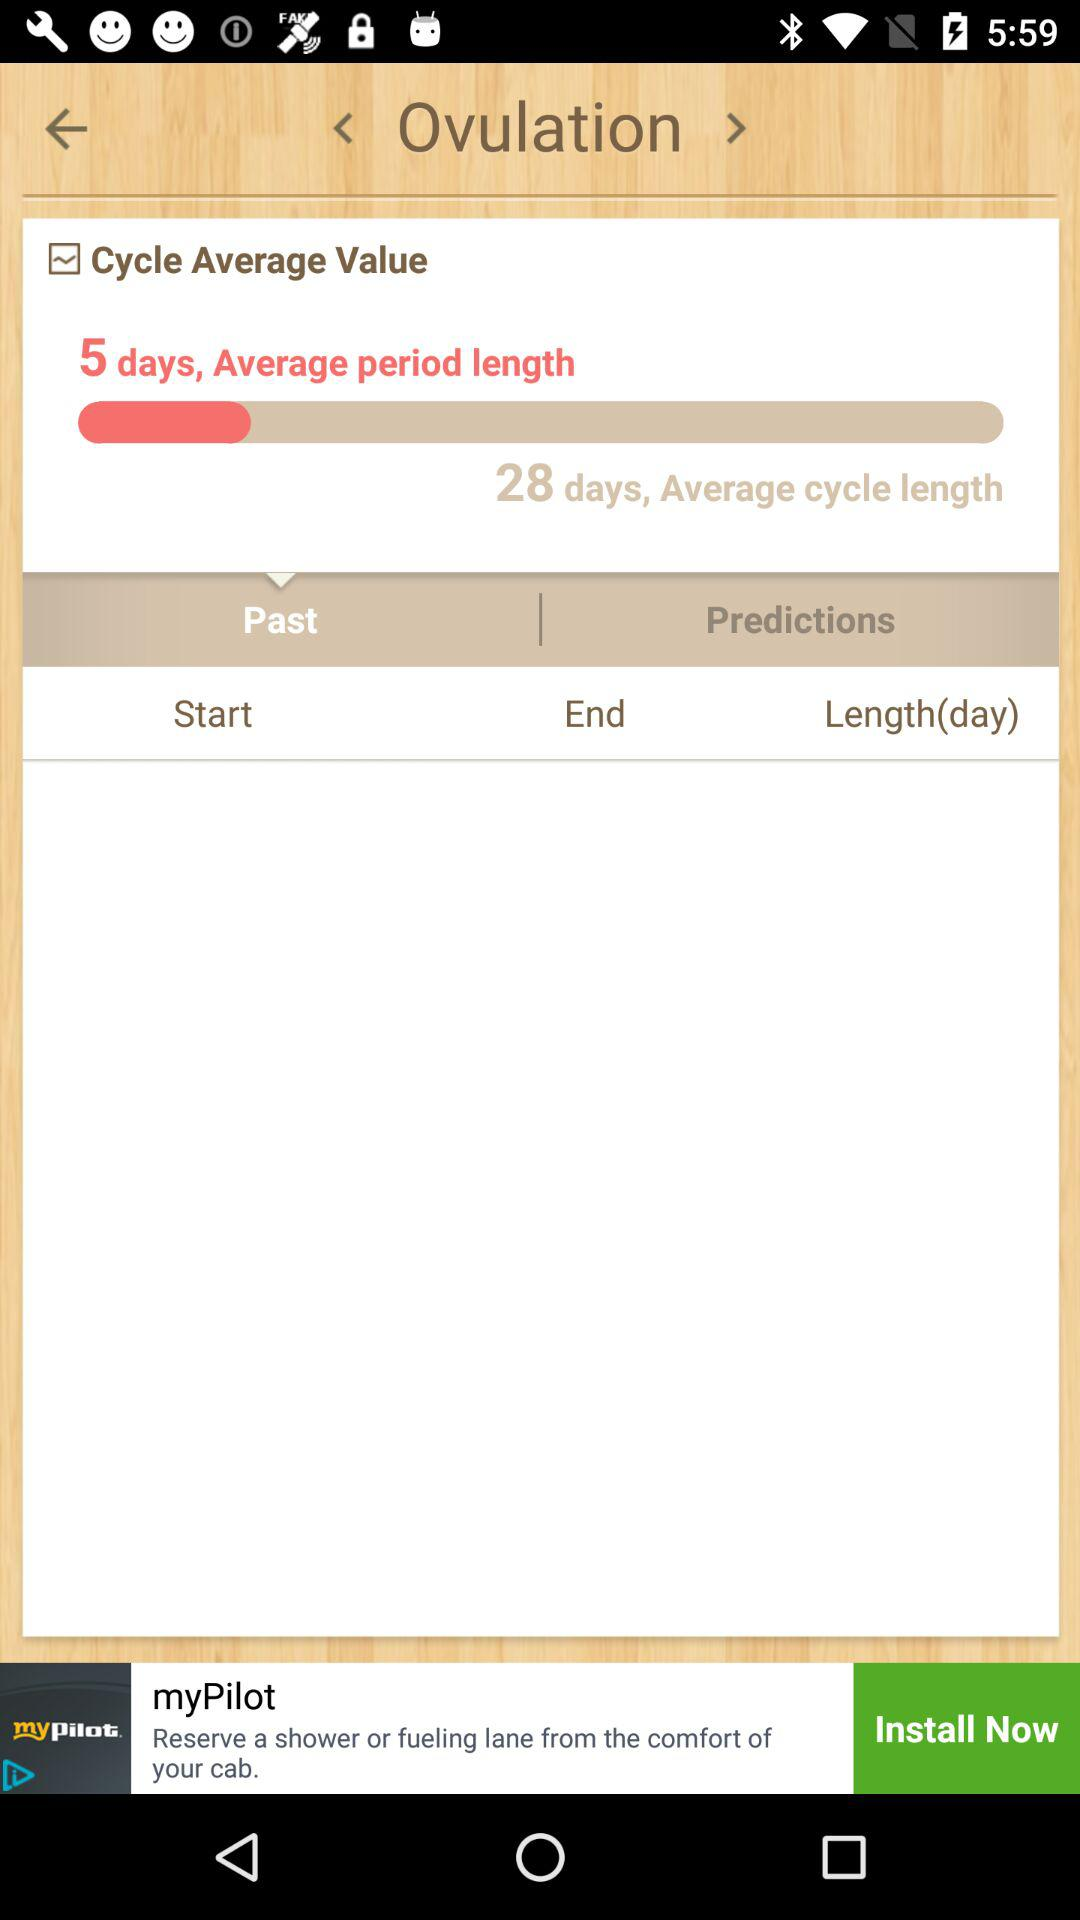How many days is the average cycle length? The average cycle length is 28 days. 